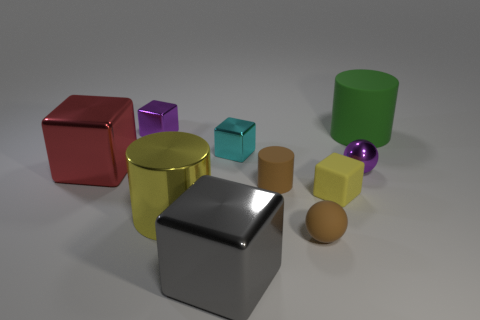There is a metallic thing that is the same color as the tiny matte block; what shape is it?
Offer a terse response. Cylinder. The rubber cube that is the same color as the large metallic cylinder is what size?
Give a very brief answer. Small. There is a big object behind the red object; what is its material?
Give a very brief answer. Rubber. Are there the same number of metallic cylinders that are behind the brown rubber cylinder and small blue metal cylinders?
Keep it short and to the point. Yes. What is the big thing on the right side of the rubber cylinder in front of the large green matte object made of?
Provide a short and direct response. Rubber. What is the shape of the shiny thing that is on the left side of the yellow cylinder and behind the large red shiny thing?
Offer a terse response. Cube. The gray thing that is the same shape as the cyan object is what size?
Ensure brevity in your answer.  Large. Are there fewer large gray metallic objects that are left of the tiny brown ball than yellow matte objects?
Your answer should be compact. No. What is the size of the metallic cube that is right of the gray block?
Provide a succinct answer. Small. The other matte thing that is the same shape as the large green matte thing is what color?
Give a very brief answer. Brown. 